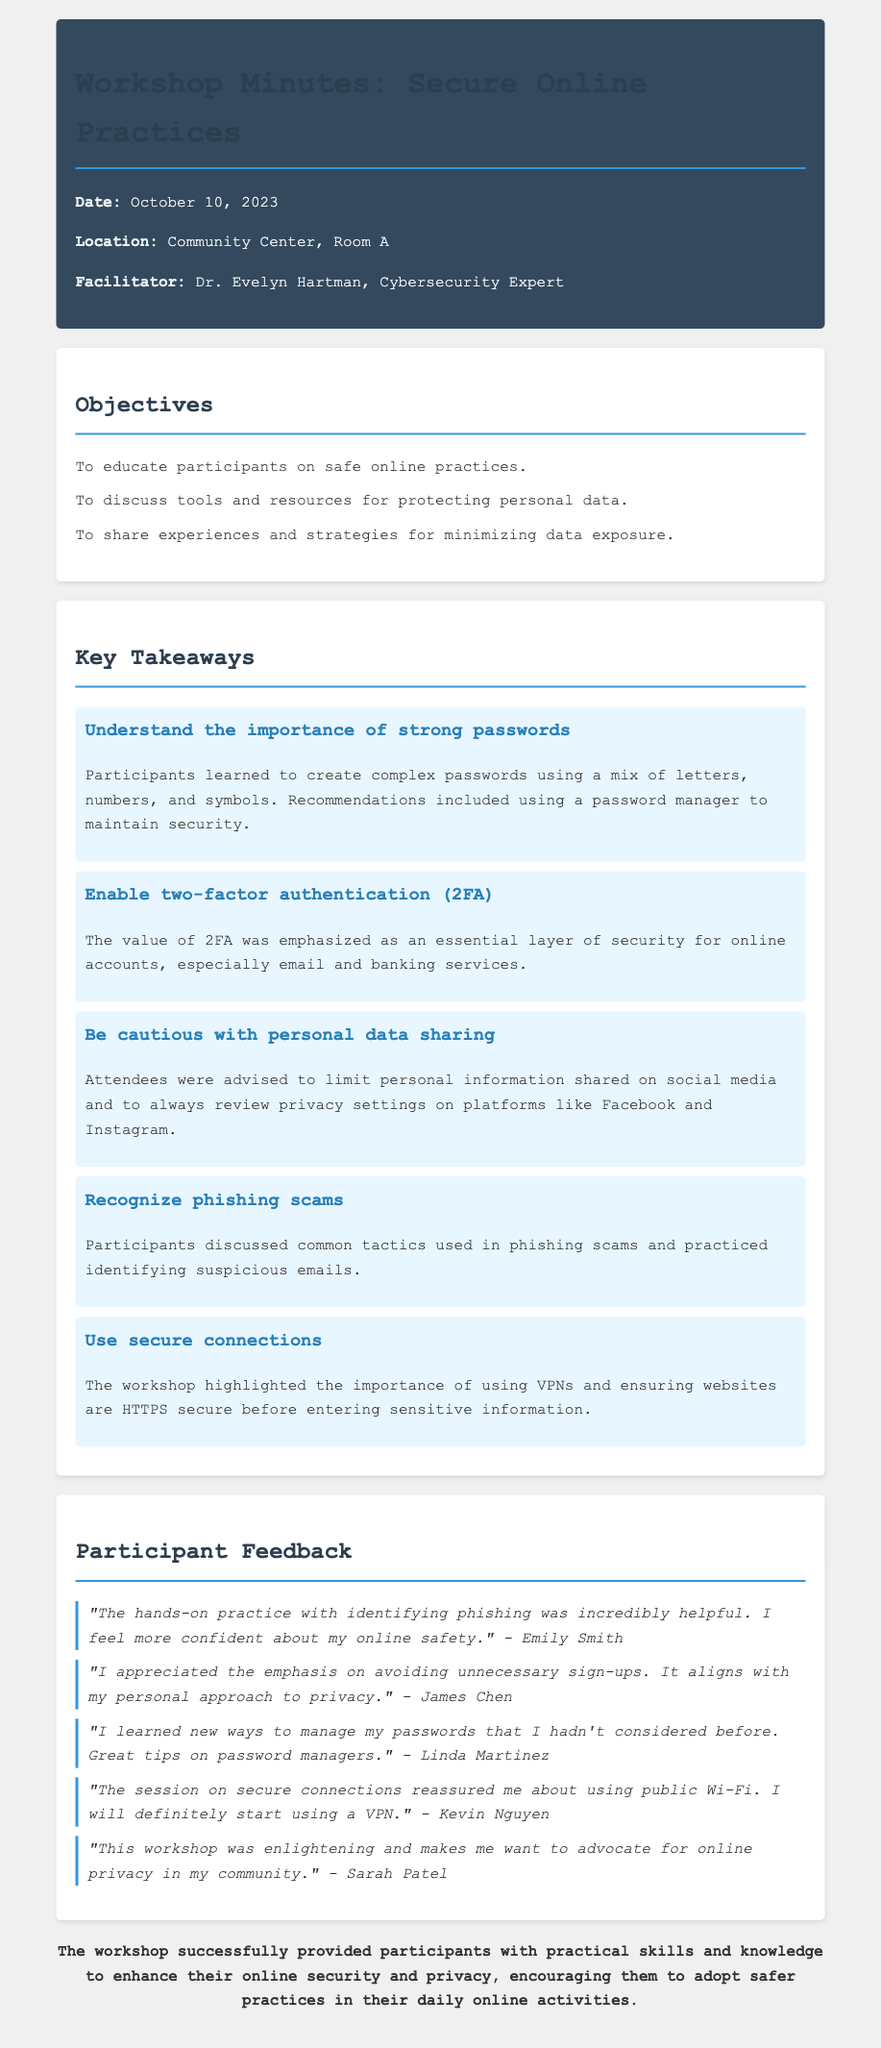What is the date of the workshop? The date of the workshop is clearly stated in the document header.
Answer: October 10, 2023 Who was the facilitator of the workshop? The facilitator's name and title are provided in the header section.
Answer: Dr. Evelyn Hartman What was one of the objectives of the workshop? Objectives are listed in a bullet point format, each outlining a focus area of the workshop.
Answer: To educate participants on safe online practices What is one key takeaway regarding passwords? The key takeaways summarize important lessons, including the focus on passwords.
Answer: Understand the importance of strong passwords Which participant felt reassured about using public Wi-Fi? Feedback includes direct quotes from participants, identifying their specific learning outcomes.
Answer: Kevin Nguyen How did James Chen feel about unnecessary sign-ups? James Chen expressed his perspective on privacy during the feedback section.
Answer: It aligns with my personal approach to privacy What security measure did participants discuss recognizing? The document mentions tactics discussed in relation to online security measures.
Answer: Phishing scams In what way did the workshop help Sarah Patel? Participant feedback highlights the impact of the workshop on individual attitudes towards online safety.
Answer: Advocate for online privacy in my community 